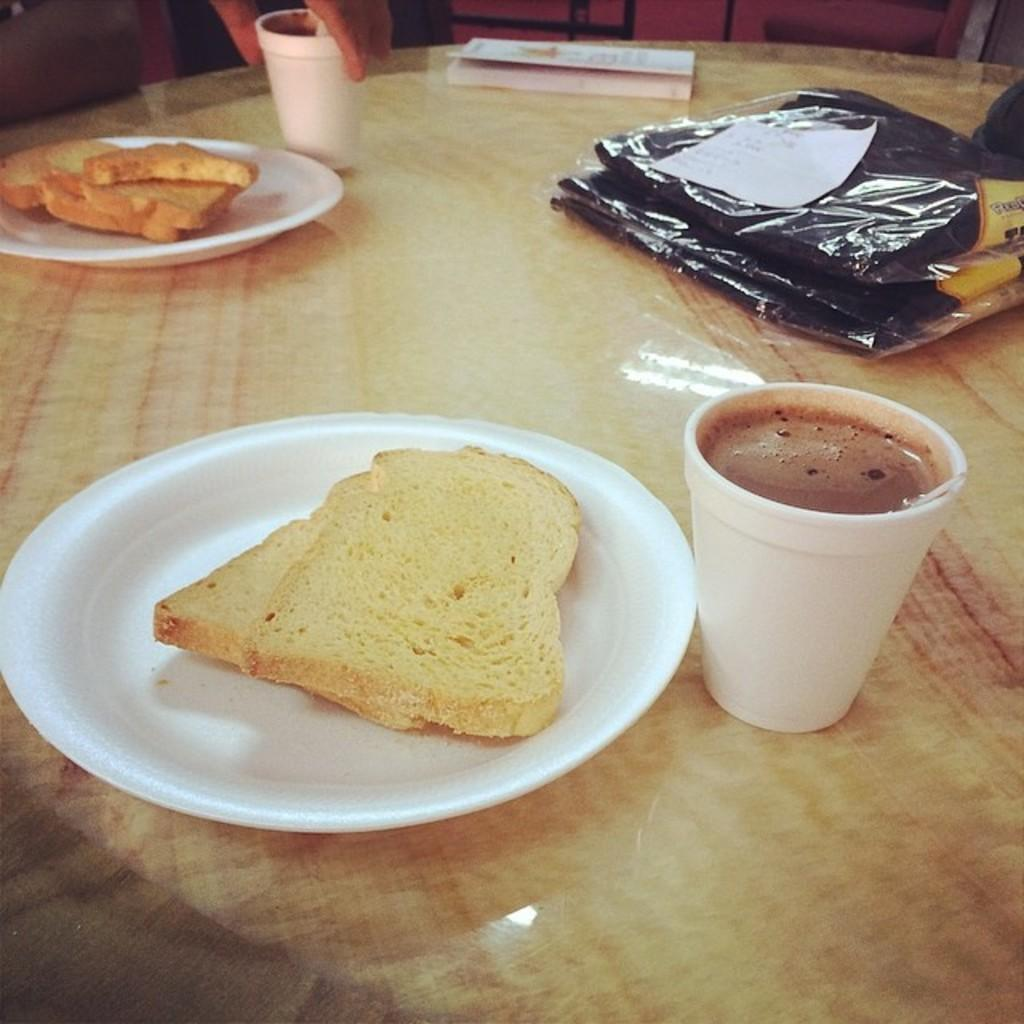What piece of furniture is present in the image? There is a table in the image. What food item can be seen on the table? There are plates with bread on the table. How many coffee cups are on the table? There are two coffee cups on the table. What else is present on the table besides food and coffee cups? There is a book and two packets on the table. Can you see a stranger climbing a mountain in the image? No, there is no stranger or mountain present in the image. 